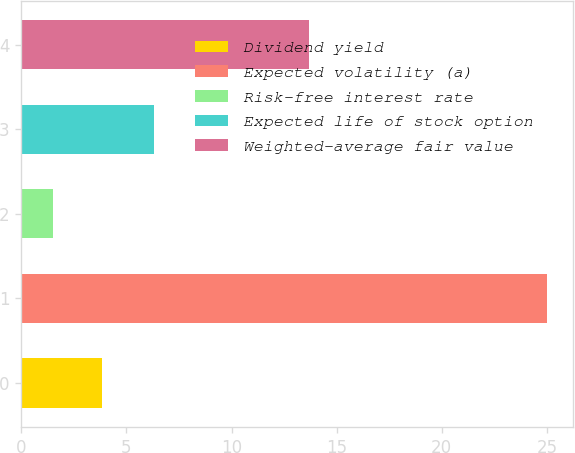Convert chart. <chart><loc_0><loc_0><loc_500><loc_500><bar_chart><fcel>Dividend yield<fcel>Expected volatility (a)<fcel>Risk-free interest rate<fcel>Expected life of stock option<fcel>Weighted-average fair value<nl><fcel>3.85<fcel>25<fcel>1.5<fcel>6.3<fcel>13.67<nl></chart> 